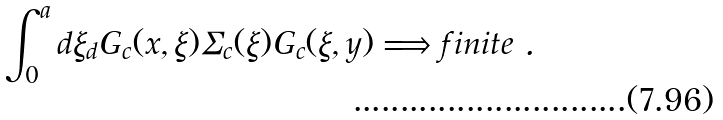Convert formula to latex. <formula><loc_0><loc_0><loc_500><loc_500>\int _ { 0 } ^ { a } d \xi _ { d } G _ { c } ( x , \xi ) \Sigma _ { c } ( \xi ) G _ { c } ( \xi , y ) \Longrightarrow f i n i t e \ .</formula> 